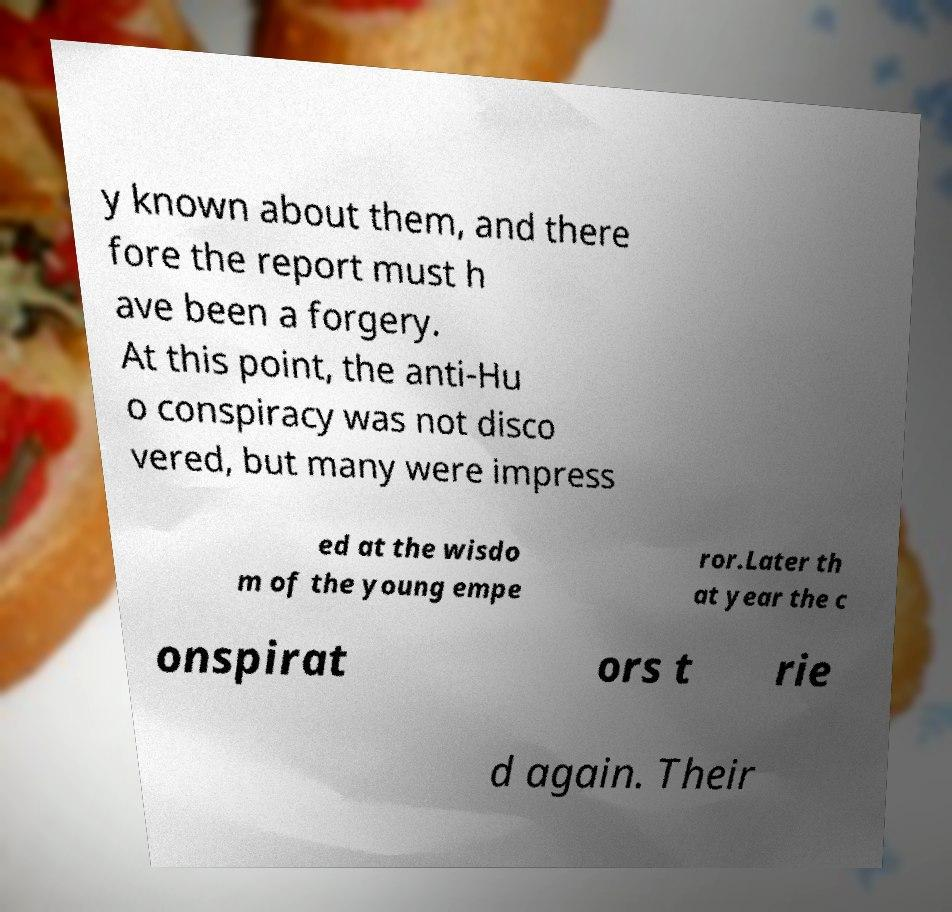Could you assist in decoding the text presented in this image and type it out clearly? y known about them, and there fore the report must h ave been a forgery. At this point, the anti-Hu o conspiracy was not disco vered, but many were impress ed at the wisdo m of the young empe ror.Later th at year the c onspirat ors t rie d again. Their 